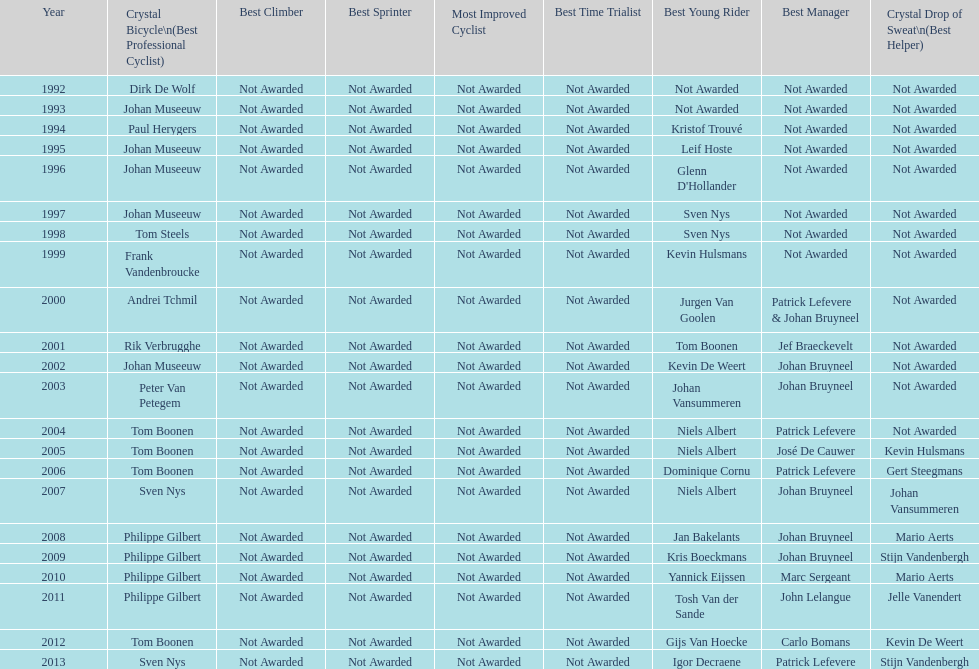Who has won the most best young rider awards? Niels Albert. 